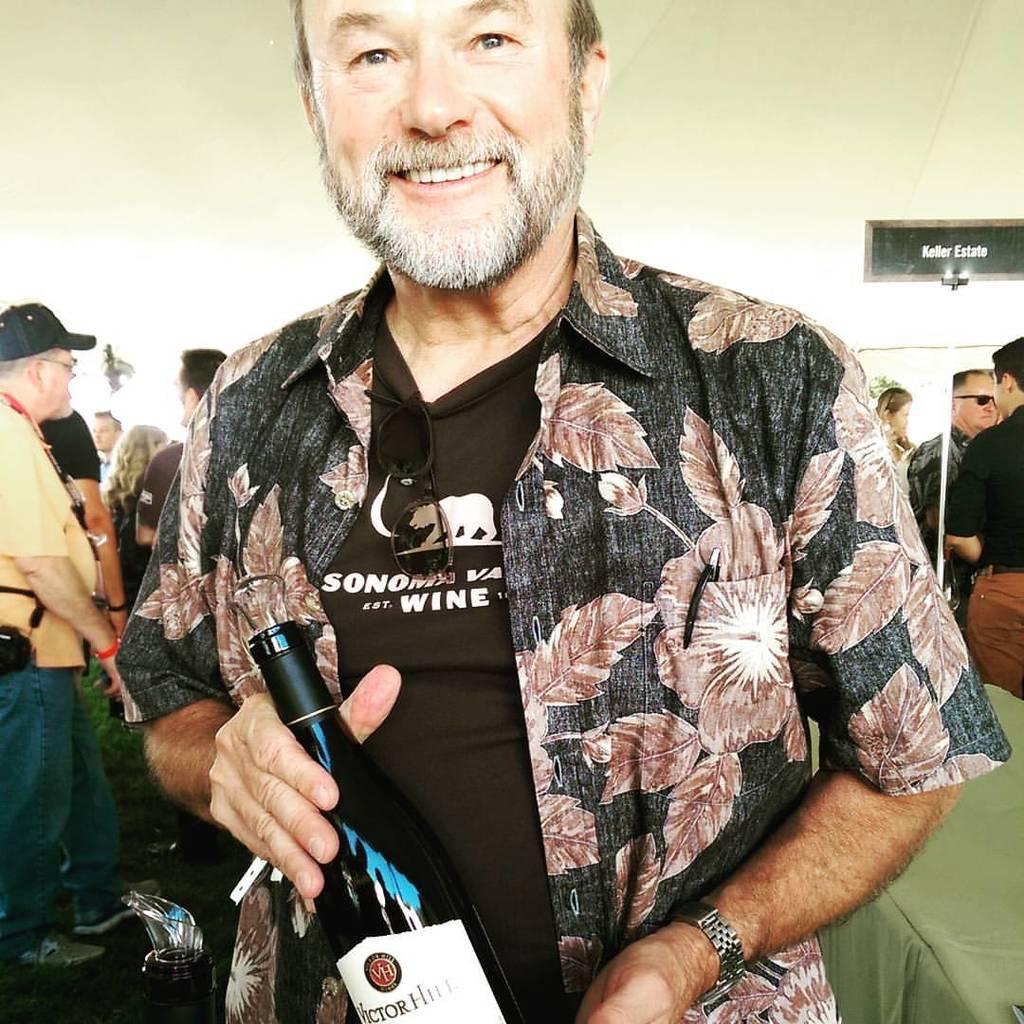What is the main subject of the image? There is a person in the image. What is the person holding in the image? The person is holding a wine bottle. Can you describe the people behind the person in the image? There is a group of people standing behind the person in the image. What type of horse can be seen grazing in the background of the image? There is no horse present in the image; it only features a person holding a wine bottle and a group of people standing behind them. 